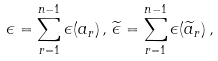<formula> <loc_0><loc_0><loc_500><loc_500>\epsilon = \sum _ { r = 1 } ^ { n - 1 } \epsilon ( a _ { r } ) \, , \, \widetilde { \epsilon } = \sum _ { r = 1 } ^ { n - 1 } \epsilon ( \widetilde { a } _ { r } ) \, ,</formula> 